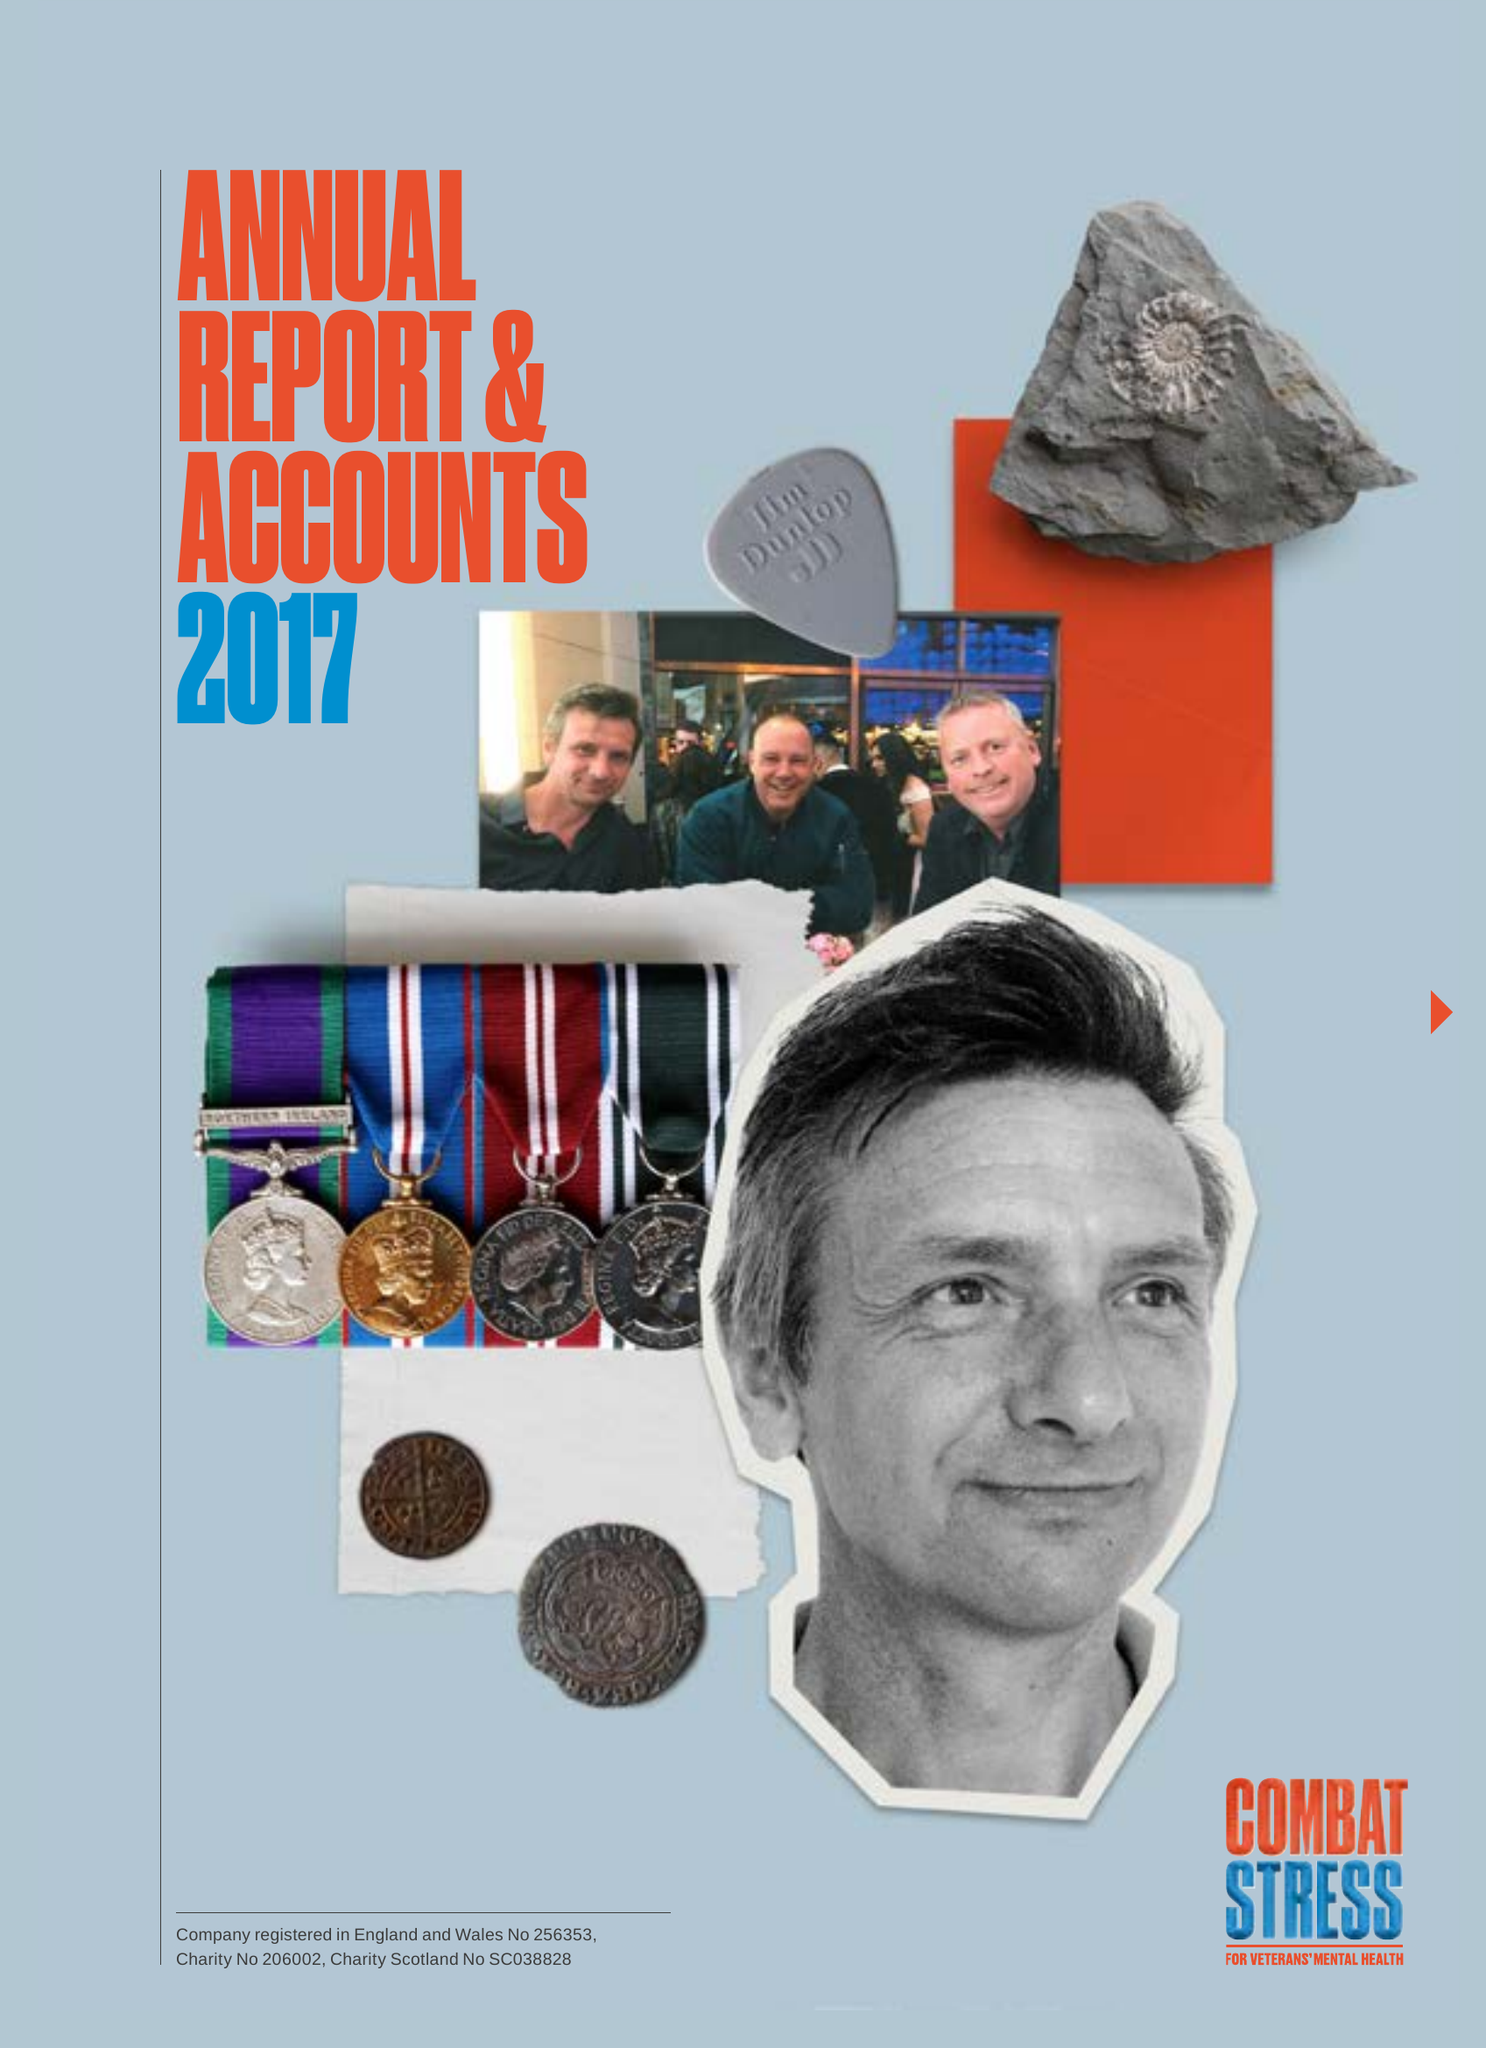What is the value for the address__street_line?
Answer the question using a single word or phrase. OAKLAWN ROAD 